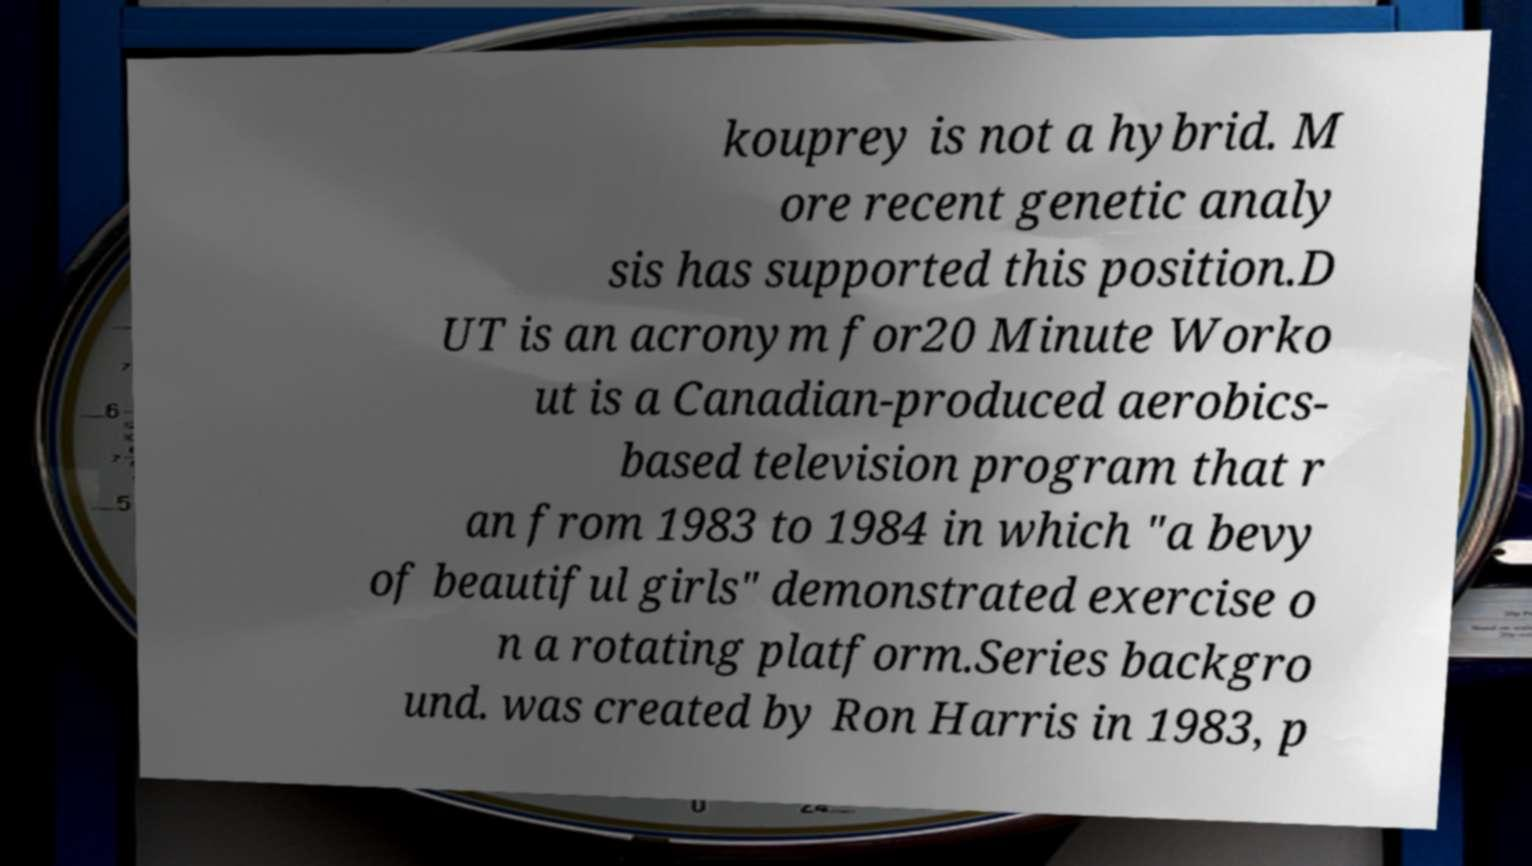I need the written content from this picture converted into text. Can you do that? kouprey is not a hybrid. M ore recent genetic analy sis has supported this position.D UT is an acronym for20 Minute Worko ut is a Canadian-produced aerobics- based television program that r an from 1983 to 1984 in which "a bevy of beautiful girls" demonstrated exercise o n a rotating platform.Series backgro und. was created by Ron Harris in 1983, p 